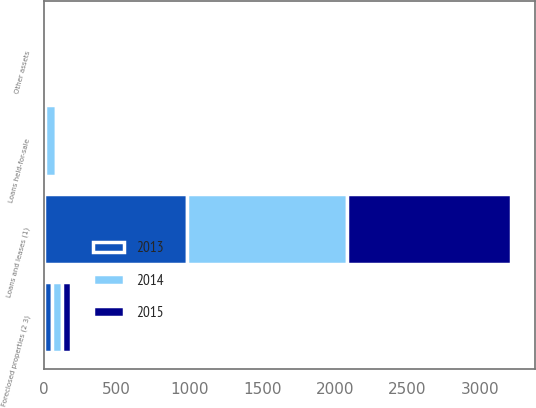Convert chart to OTSL. <chart><loc_0><loc_0><loc_500><loc_500><stacked_bar_chart><ecel><fcel>Loans held-for-sale<fcel>Loans and leases (1)<fcel>Foreclosed properties (2 3)<fcel>Other assets<nl><fcel>2013<fcel>8<fcel>980<fcel>57<fcel>15<nl><fcel>2015<fcel>19<fcel>1132<fcel>66<fcel>6<nl><fcel>2014<fcel>71<fcel>1104<fcel>63<fcel>20<nl></chart> 